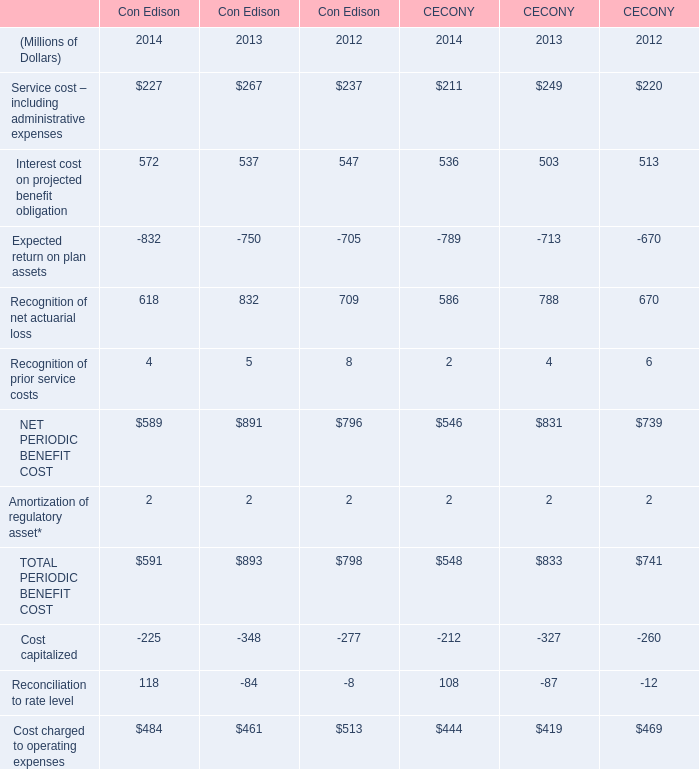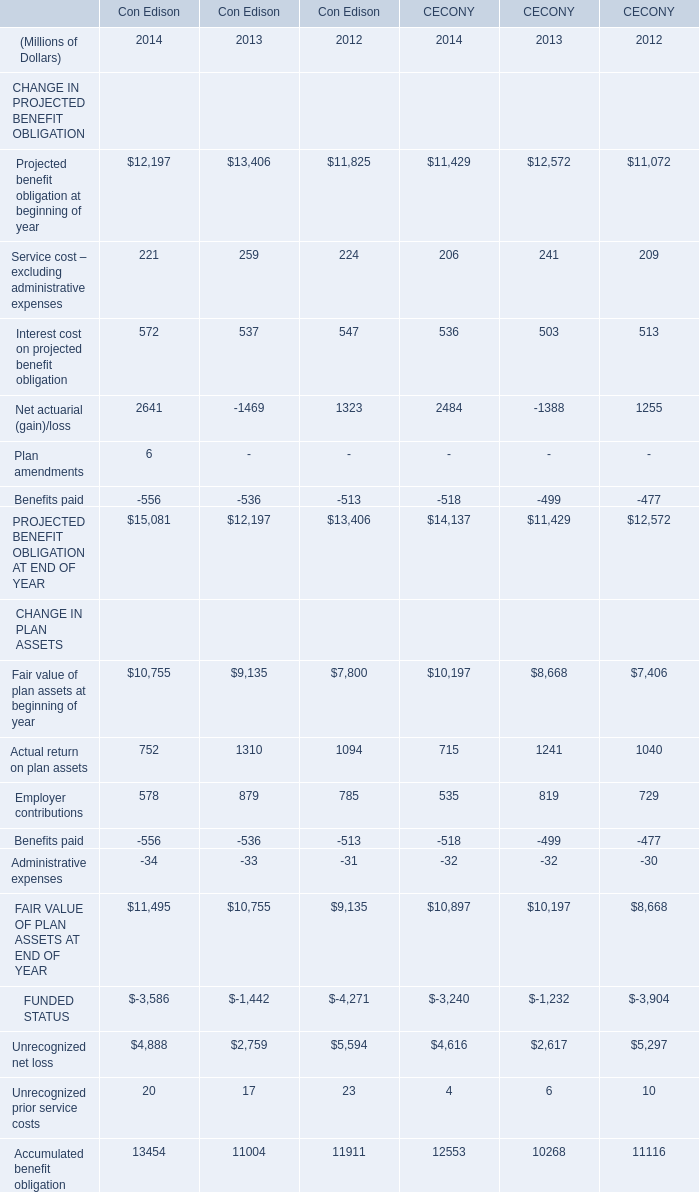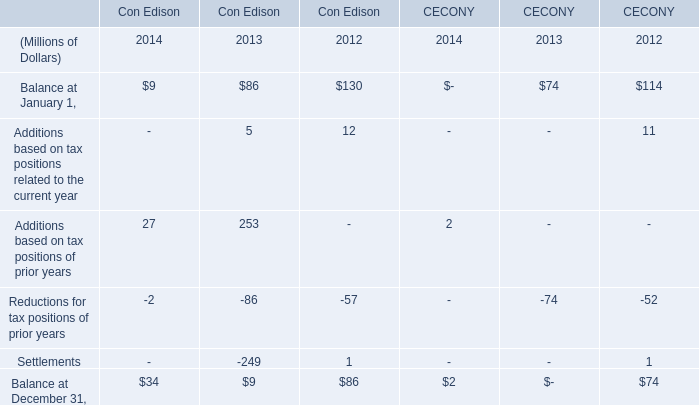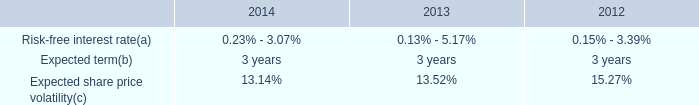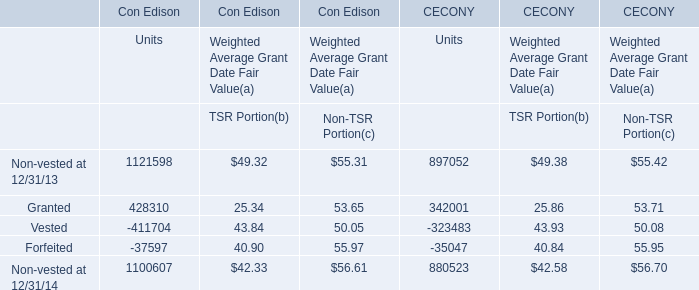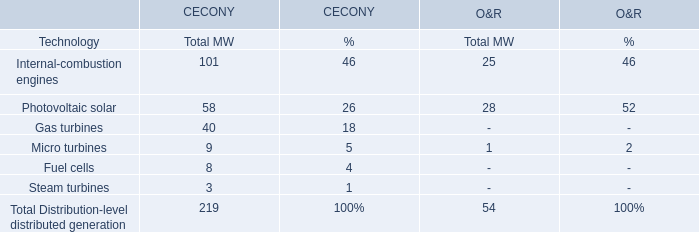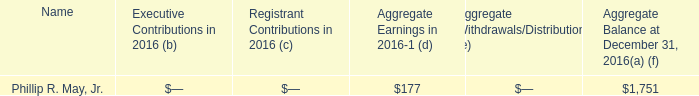In the year with lowest amount of Interest cost for CECONY, what's the increasing rate of net actuarial loss? 
Computations: ((788 - 670) / 670)
Answer: 0.17612. 